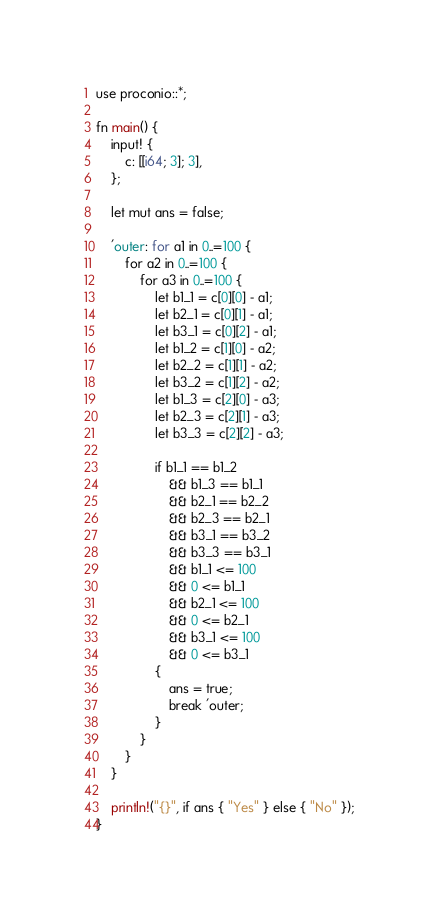<code> <loc_0><loc_0><loc_500><loc_500><_Rust_>use proconio::*;

fn main() {
    input! {
        c: [[i64; 3]; 3],
    };

    let mut ans = false;

    'outer: for a1 in 0..=100 {
        for a2 in 0..=100 {
            for a3 in 0..=100 {
                let b1_1 = c[0][0] - a1;
                let b2_1 = c[0][1] - a1;
                let b3_1 = c[0][2] - a1;
                let b1_2 = c[1][0] - a2;
                let b2_2 = c[1][1] - a2;
                let b3_2 = c[1][2] - a2;
                let b1_3 = c[2][0] - a3;
                let b2_3 = c[2][1] - a3;
                let b3_3 = c[2][2] - a3;

                if b1_1 == b1_2
                    && b1_3 == b1_1
                    && b2_1 == b2_2
                    && b2_3 == b2_1
                    && b3_1 == b3_2
                    && b3_3 == b3_1
                    && b1_1 <= 100
                    && 0 <= b1_1
                    && b2_1 <= 100
                    && 0 <= b2_1
                    && b3_1 <= 100
                    && 0 <= b3_1
                {
                    ans = true;
                    break 'outer;
                }
            }
        }
    }

    println!("{}", if ans { "Yes" } else { "No" });
}
</code> 